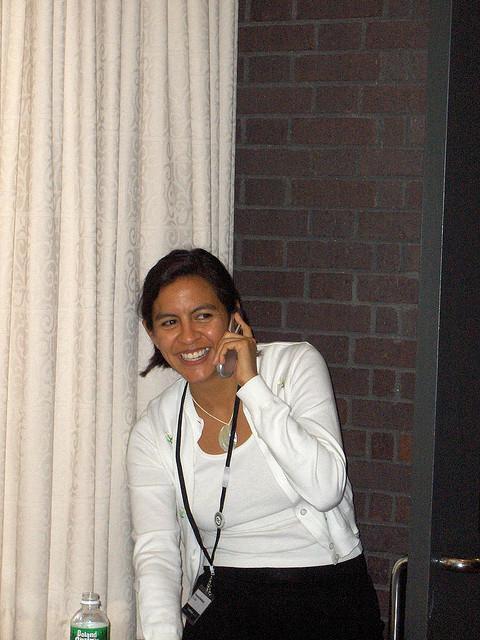How is she communicating?
Select the accurate answer and provide explanation: 'Answer: answer
Rationale: rationale.'
Options: Shouting, telegraph, computer, phone. Answer: phone.
Rationale: The woman is holding an item to her ear which would not be required to talk on a computer or telegraph and she does not appear to be shouting 